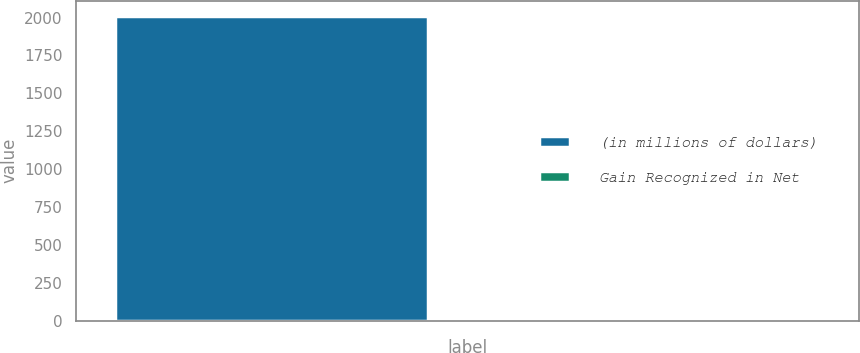Convert chart to OTSL. <chart><loc_0><loc_0><loc_500><loc_500><bar_chart><fcel>(in millions of dollars)<fcel>Gain Recognized in Net<nl><fcel>2010<fcel>21.1<nl></chart> 